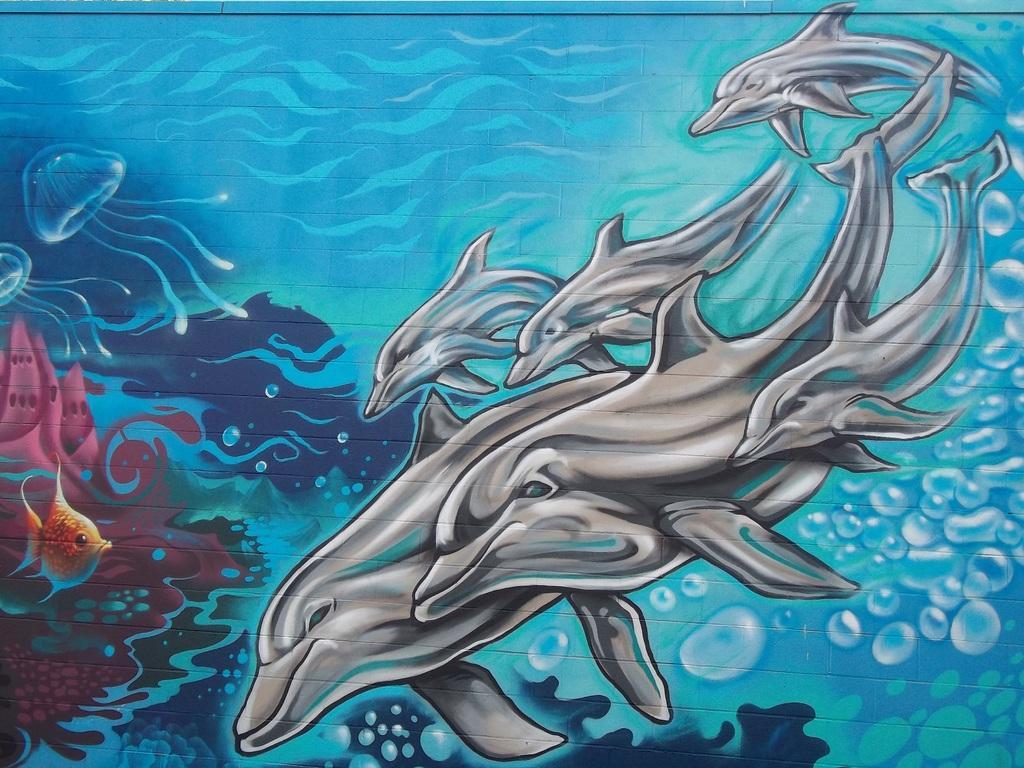How would you summarize this image in a sentence or two? In the image we can see a painting on wall. In the painting we can see some fishes and dolphins. 